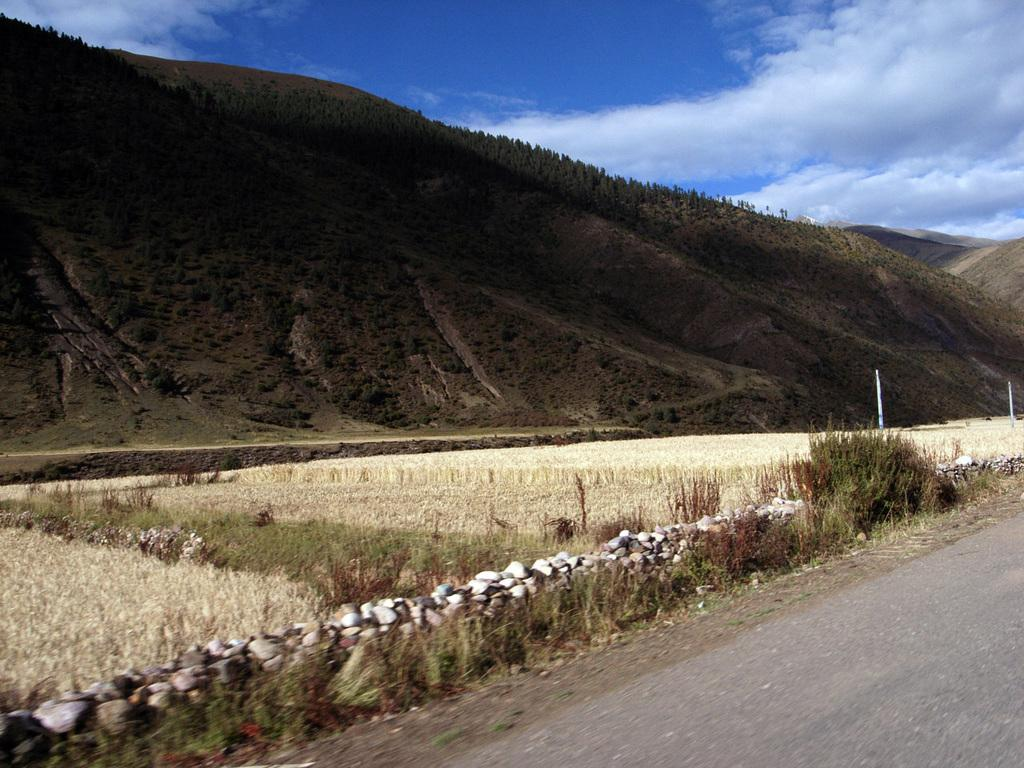What is the main feature of the image? There is a road in the image. What can be seen beside the road? There is grass beside the road. What is visible in the background of the image? There are mountains filled with trees in the image. What is visible in the sky? Clouds are visible in the sky. What type of sound can be heard coming from the alley in the image? There is no alley present in the image, so it's not possible to determine what, if any, sounds might be heard. 